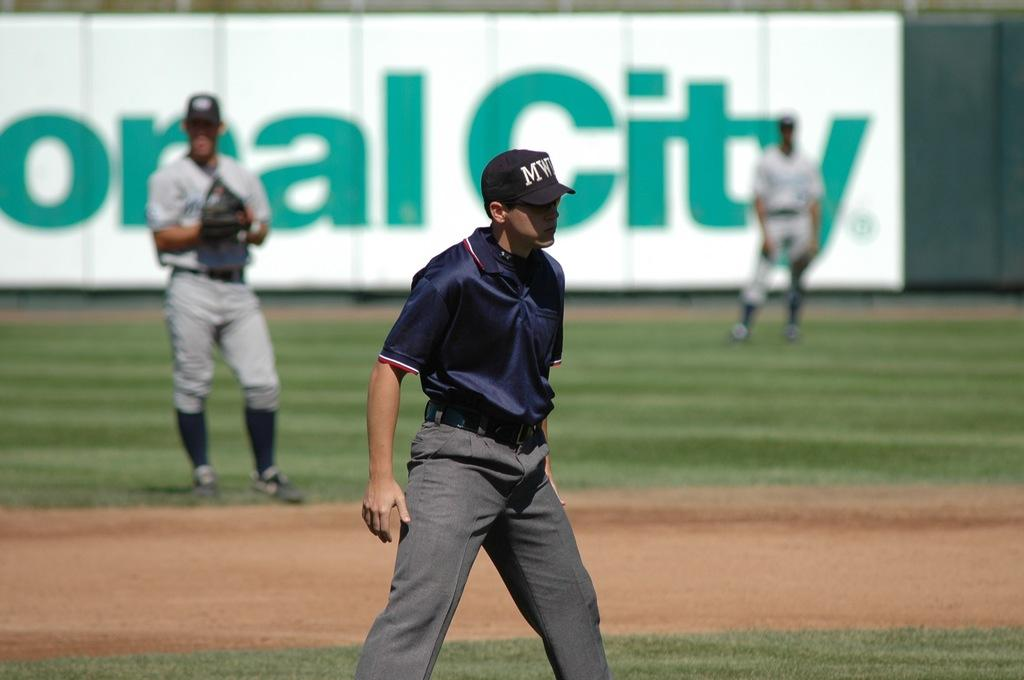<image>
Create a compact narrative representing the image presented. A baseball field has a large banner in the back that reads "City" in green letters. 